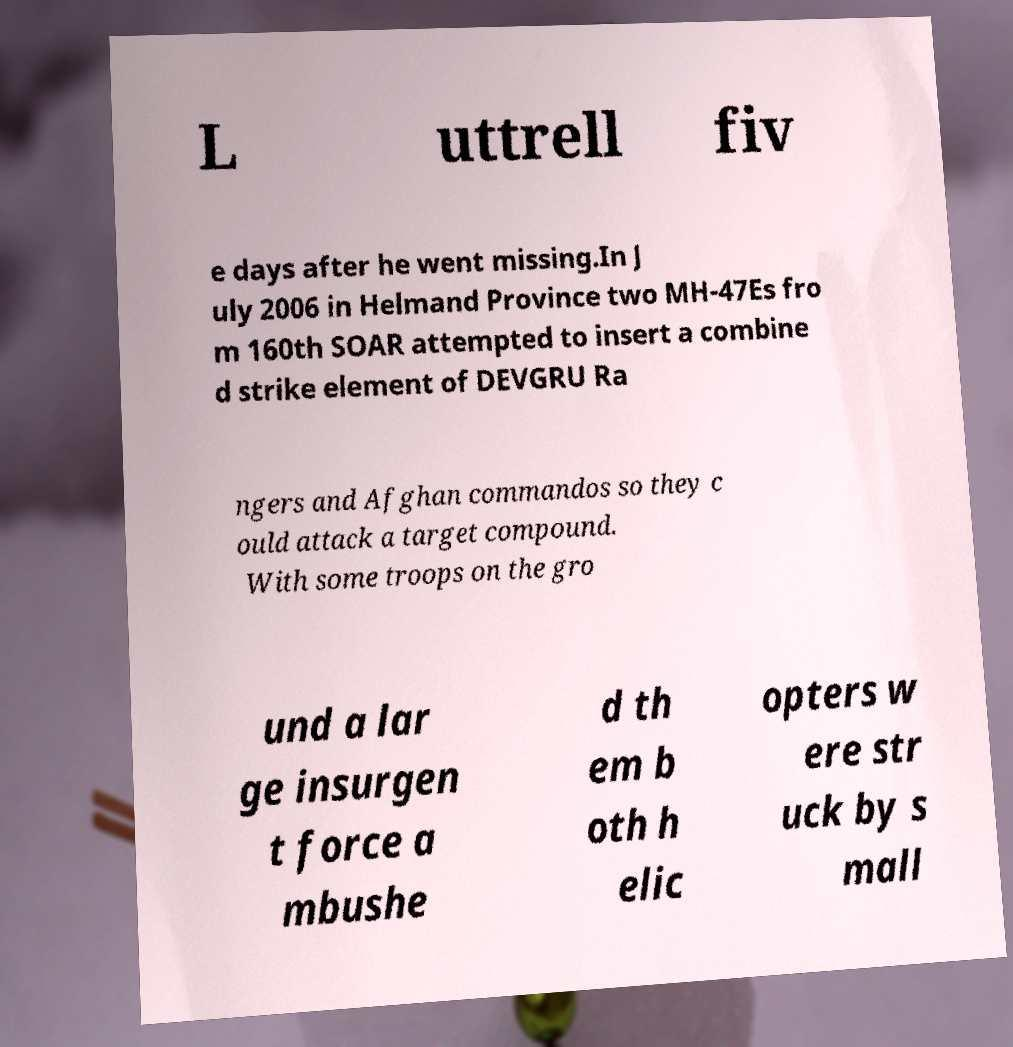Can you accurately transcribe the text from the provided image for me? L uttrell fiv e days after he went missing.In J uly 2006 in Helmand Province two MH-47Es fro m 160th SOAR attempted to insert a combine d strike element of DEVGRU Ra ngers and Afghan commandos so they c ould attack a target compound. With some troops on the gro und a lar ge insurgen t force a mbushe d th em b oth h elic opters w ere str uck by s mall 